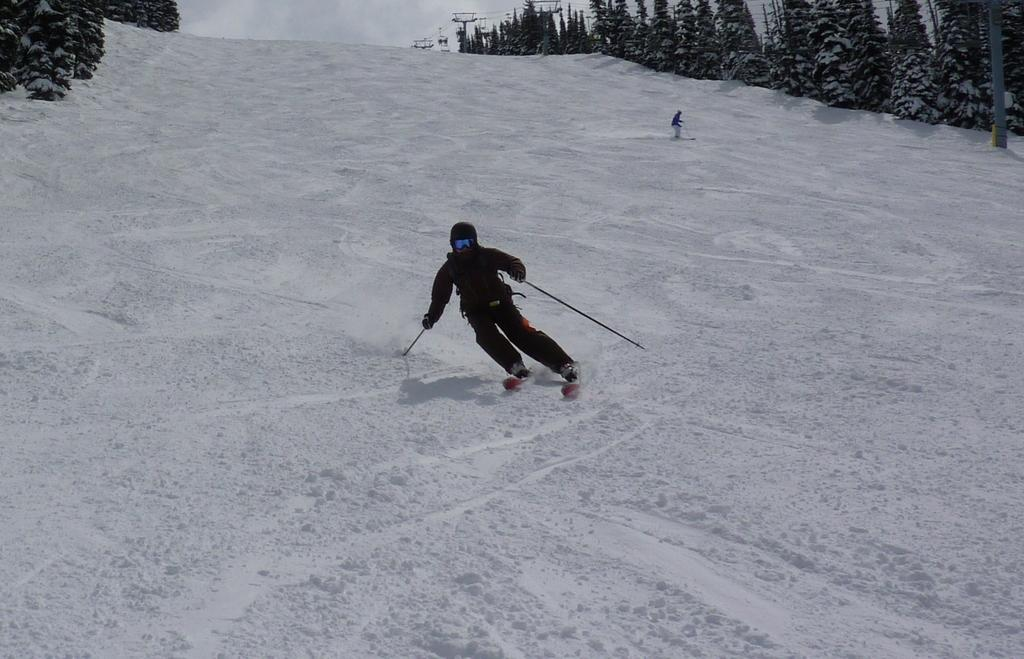How many people are in the image? There are two persons in the image. What are the persons doing in the image? The persons are skiing. In what environment is the skiing taking place? The skiing is taking place in snow. What can be seen in the background of the image? There are trees covered with snow on either side of the persons. What type of dog can be seen running alongside the skiers in the image? There is no dog present in the image; the persons are skiing alone. 